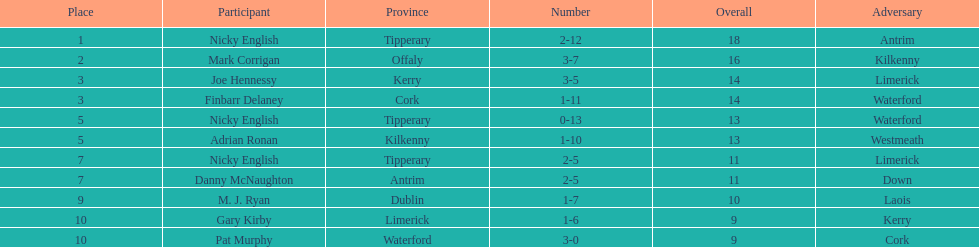Joe hennessy and finbarr delaney both scored how many points? 14. 